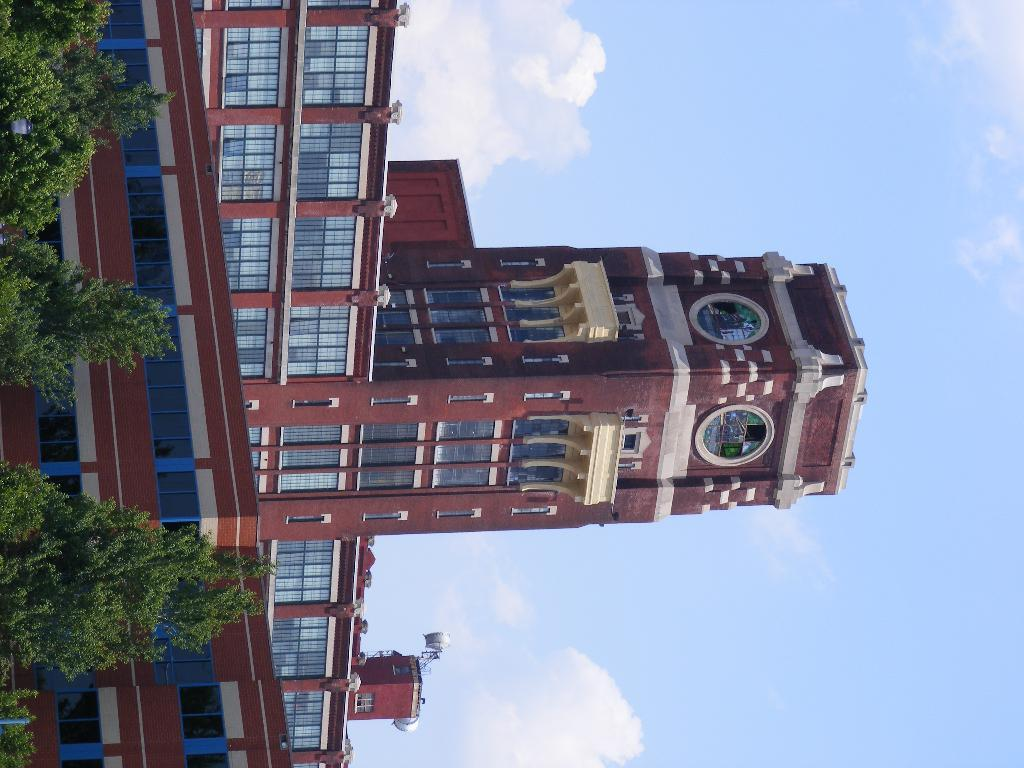What type of vegetation is on the left side of the image? There are trees on the left side of the image. What can be seen in the background of the image? There is a building in the background of the image. What is visible at the top of the image? The sky is visible at the top of the image. What type of juice is being tested in the image? There is no juice or testing activity present in the image. How much tax is being paid for the building in the image? There is no information about taxes in the image, as it only shows trees, a building, and the sky. 